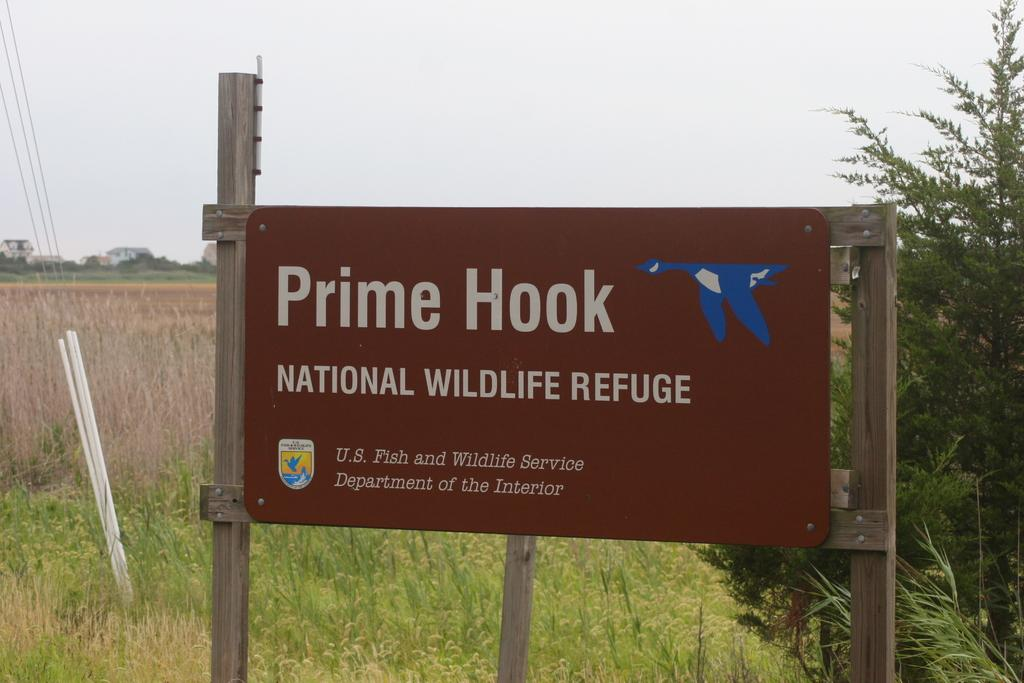What is the main object in the center of the image? There is a board in the center of the image. What can be seen in the background of the image? There are plants, buildings, and the sky visible in the background of the image. What type of gold is being delivered by the porter in the image? There is no porter or gold present in the image; it only features a board and background elements. 